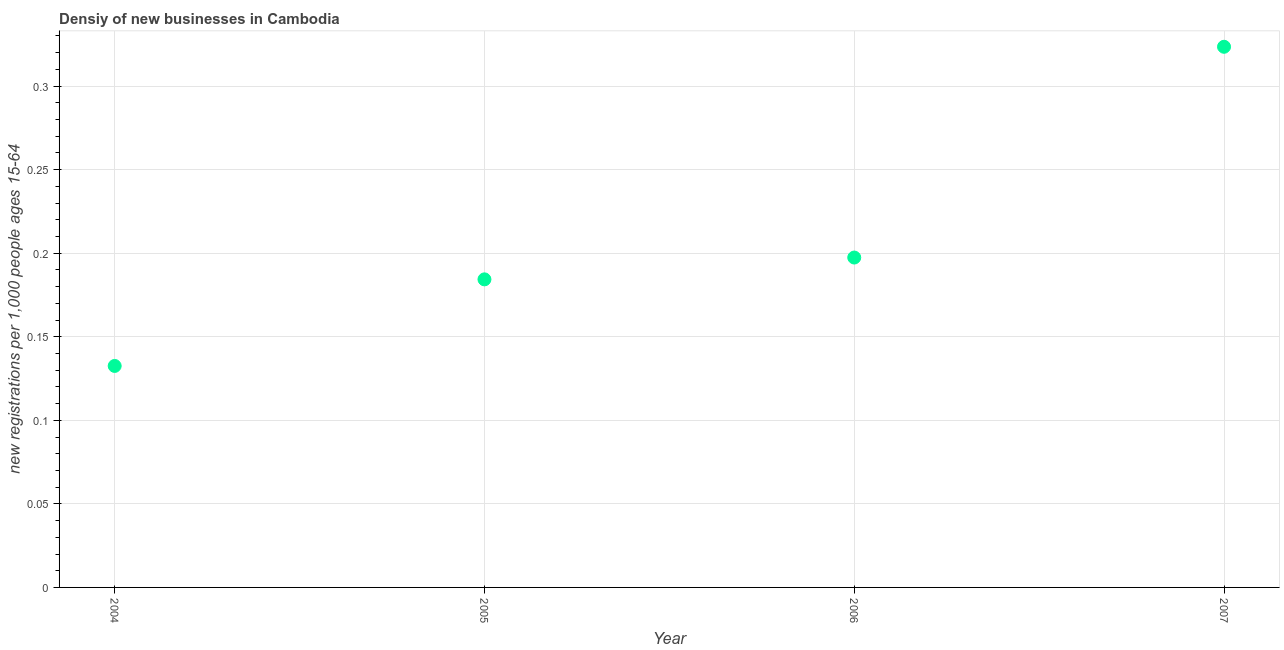What is the density of new business in 2006?
Offer a terse response. 0.2. Across all years, what is the maximum density of new business?
Your answer should be very brief. 0.32. Across all years, what is the minimum density of new business?
Give a very brief answer. 0.13. In which year was the density of new business maximum?
Your answer should be compact. 2007. In which year was the density of new business minimum?
Ensure brevity in your answer.  2004. What is the sum of the density of new business?
Give a very brief answer. 0.84. What is the difference between the density of new business in 2005 and 2007?
Ensure brevity in your answer.  -0.14. What is the average density of new business per year?
Your response must be concise. 0.21. What is the median density of new business?
Provide a succinct answer. 0.19. Do a majority of the years between 2007 and 2005 (inclusive) have density of new business greater than 0.25 ?
Offer a terse response. No. What is the ratio of the density of new business in 2004 to that in 2005?
Offer a very short reply. 0.72. Is the density of new business in 2005 less than that in 2006?
Your answer should be very brief. Yes. Is the difference between the density of new business in 2005 and 2007 greater than the difference between any two years?
Provide a short and direct response. No. What is the difference between the highest and the second highest density of new business?
Provide a succinct answer. 0.13. What is the difference between the highest and the lowest density of new business?
Offer a very short reply. 0.19. In how many years, is the density of new business greater than the average density of new business taken over all years?
Your response must be concise. 1. How many dotlines are there?
Your answer should be compact. 1. What is the difference between two consecutive major ticks on the Y-axis?
Your response must be concise. 0.05. Are the values on the major ticks of Y-axis written in scientific E-notation?
Provide a short and direct response. No. Does the graph contain grids?
Ensure brevity in your answer.  Yes. What is the title of the graph?
Ensure brevity in your answer.  Densiy of new businesses in Cambodia. What is the label or title of the X-axis?
Offer a terse response. Year. What is the label or title of the Y-axis?
Your answer should be very brief. New registrations per 1,0 people ages 15-64. What is the new registrations per 1,000 people ages 15-64 in 2004?
Give a very brief answer. 0.13. What is the new registrations per 1,000 people ages 15-64 in 2005?
Make the answer very short. 0.18. What is the new registrations per 1,000 people ages 15-64 in 2006?
Your answer should be very brief. 0.2. What is the new registrations per 1,000 people ages 15-64 in 2007?
Give a very brief answer. 0.32. What is the difference between the new registrations per 1,000 people ages 15-64 in 2004 and 2005?
Your response must be concise. -0.05. What is the difference between the new registrations per 1,000 people ages 15-64 in 2004 and 2006?
Provide a short and direct response. -0.06. What is the difference between the new registrations per 1,000 people ages 15-64 in 2004 and 2007?
Offer a terse response. -0.19. What is the difference between the new registrations per 1,000 people ages 15-64 in 2005 and 2006?
Give a very brief answer. -0.01. What is the difference between the new registrations per 1,000 people ages 15-64 in 2005 and 2007?
Offer a very short reply. -0.14. What is the difference between the new registrations per 1,000 people ages 15-64 in 2006 and 2007?
Make the answer very short. -0.13. What is the ratio of the new registrations per 1,000 people ages 15-64 in 2004 to that in 2005?
Offer a terse response. 0.72. What is the ratio of the new registrations per 1,000 people ages 15-64 in 2004 to that in 2006?
Ensure brevity in your answer.  0.67. What is the ratio of the new registrations per 1,000 people ages 15-64 in 2004 to that in 2007?
Your answer should be compact. 0.41. What is the ratio of the new registrations per 1,000 people ages 15-64 in 2005 to that in 2006?
Offer a terse response. 0.93. What is the ratio of the new registrations per 1,000 people ages 15-64 in 2005 to that in 2007?
Offer a terse response. 0.57. What is the ratio of the new registrations per 1,000 people ages 15-64 in 2006 to that in 2007?
Provide a short and direct response. 0.61. 